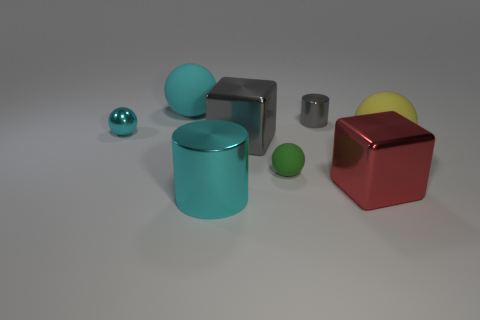What is the shape of the thing that is on the left side of the big cyan rubber sphere?
Give a very brief answer. Sphere. What number of yellow objects have the same shape as the big cyan matte object?
Make the answer very short. 1. What number of green things are either tiny metal cylinders or shiny spheres?
Keep it short and to the point. 0. There is a gray shiny thing that is in front of the cyan metal sphere to the left of the big yellow rubber object; how big is it?
Make the answer very short. Large. What is the material of the gray thing that is the same shape as the large red metal thing?
Keep it short and to the point. Metal. What number of gray cylinders are the same size as the green matte thing?
Provide a succinct answer. 1. Is the size of the gray cylinder the same as the cyan matte sphere?
Keep it short and to the point. No. There is a matte sphere that is both in front of the big gray metal block and left of the tiny gray object; what size is it?
Offer a very short reply. Small. Is the number of large metal cubes left of the tiny gray thing greater than the number of green balls that are behind the big shiny cylinder?
Offer a very short reply. No. What color is the other big object that is the same shape as the big gray metal object?
Ensure brevity in your answer.  Red. 